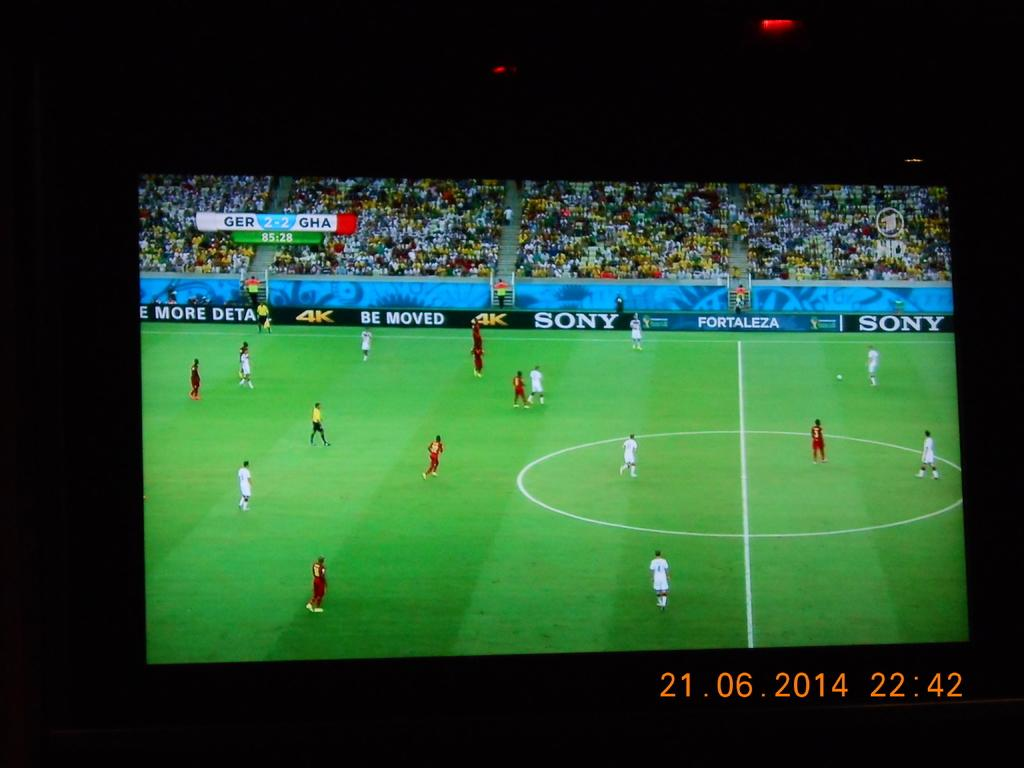<image>
Give a short and clear explanation of the subsequent image. The sony corporation has advertisements around a soccer field. 